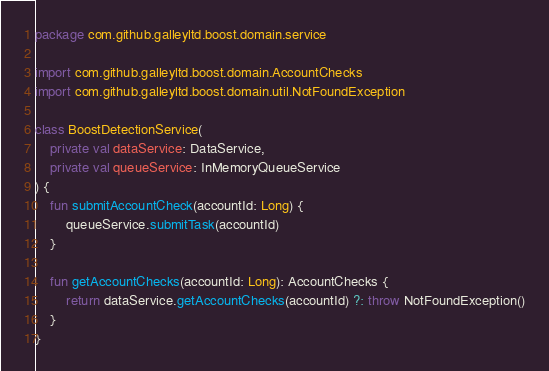<code> <loc_0><loc_0><loc_500><loc_500><_Kotlin_>package com.github.galleyltd.boost.domain.service

import com.github.galleyltd.boost.domain.AccountChecks
import com.github.galleyltd.boost.domain.util.NotFoundException

class BoostDetectionService(
    private val dataService: DataService,
    private val queueService: InMemoryQueueService
) {
    fun submitAccountCheck(accountId: Long) {
        queueService.submitTask(accountId)
    }

    fun getAccountChecks(accountId: Long): AccountChecks {
        return dataService.getAccountChecks(accountId) ?: throw NotFoundException()
    }
}
</code> 